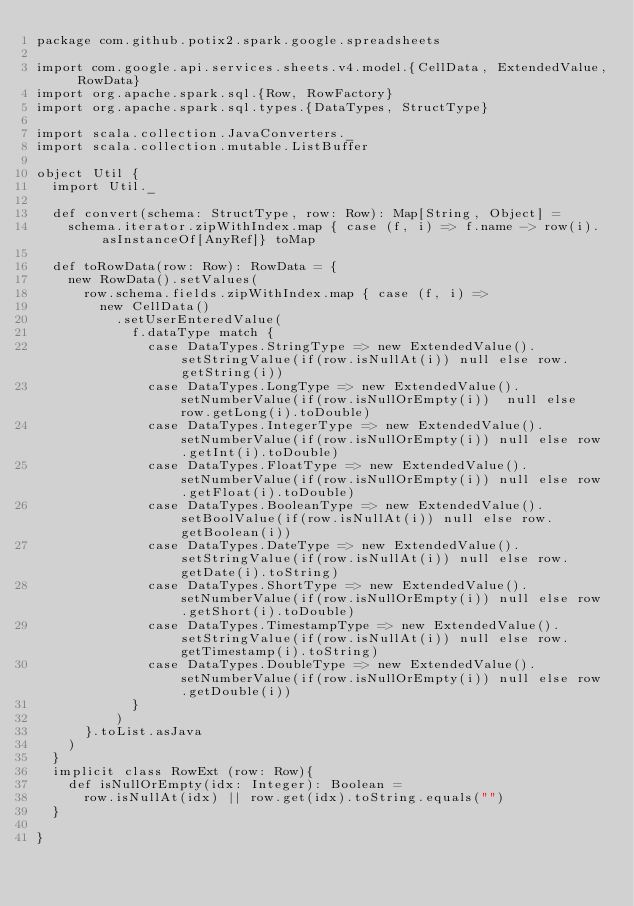Convert code to text. <code><loc_0><loc_0><loc_500><loc_500><_Scala_>package com.github.potix2.spark.google.spreadsheets

import com.google.api.services.sheets.v4.model.{CellData, ExtendedValue, RowData}
import org.apache.spark.sql.{Row, RowFactory}
import org.apache.spark.sql.types.{DataTypes, StructType}

import scala.collection.JavaConverters._
import scala.collection.mutable.ListBuffer

object Util {
  import Util._

  def convert(schema: StructType, row: Row): Map[String, Object] =
    schema.iterator.zipWithIndex.map { case (f, i) => f.name -> row(i).asInstanceOf[AnyRef]} toMap

  def toRowData(row: Row): RowData = {
    new RowData().setValues(
      row.schema.fields.zipWithIndex.map { case (f, i) =>
        new CellData()
          .setUserEnteredValue(
            f.dataType match {
              case DataTypes.StringType => new ExtendedValue().setStringValue(if(row.isNullAt(i)) null else row.getString(i))
              case DataTypes.LongType => new ExtendedValue().setNumberValue(if(row.isNullOrEmpty(i))  null else row.getLong(i).toDouble)
              case DataTypes.IntegerType => new ExtendedValue().setNumberValue(if(row.isNullOrEmpty(i)) null else row.getInt(i).toDouble)
              case DataTypes.FloatType => new ExtendedValue().setNumberValue(if(row.isNullOrEmpty(i)) null else row.getFloat(i).toDouble)
              case DataTypes.BooleanType => new ExtendedValue().setBoolValue(if(row.isNullAt(i)) null else row.getBoolean(i))
              case DataTypes.DateType => new ExtendedValue().setStringValue(if(row.isNullAt(i)) null else row.getDate(i).toString)
              case DataTypes.ShortType => new ExtendedValue().setNumberValue(if(row.isNullOrEmpty(i)) null else row.getShort(i).toDouble)
              case DataTypes.TimestampType => new ExtendedValue().setStringValue(if(row.isNullAt(i)) null else row.getTimestamp(i).toString)
              case DataTypes.DoubleType => new ExtendedValue().setNumberValue(if(row.isNullOrEmpty(i)) null else row.getDouble(i))
            }
          )
      }.toList.asJava
    )
  }
  implicit class RowExt (row: Row){
    def isNullOrEmpty(idx: Integer): Boolean =
      row.isNullAt(idx) || row.get(idx).toString.equals("")
  }

}
</code> 